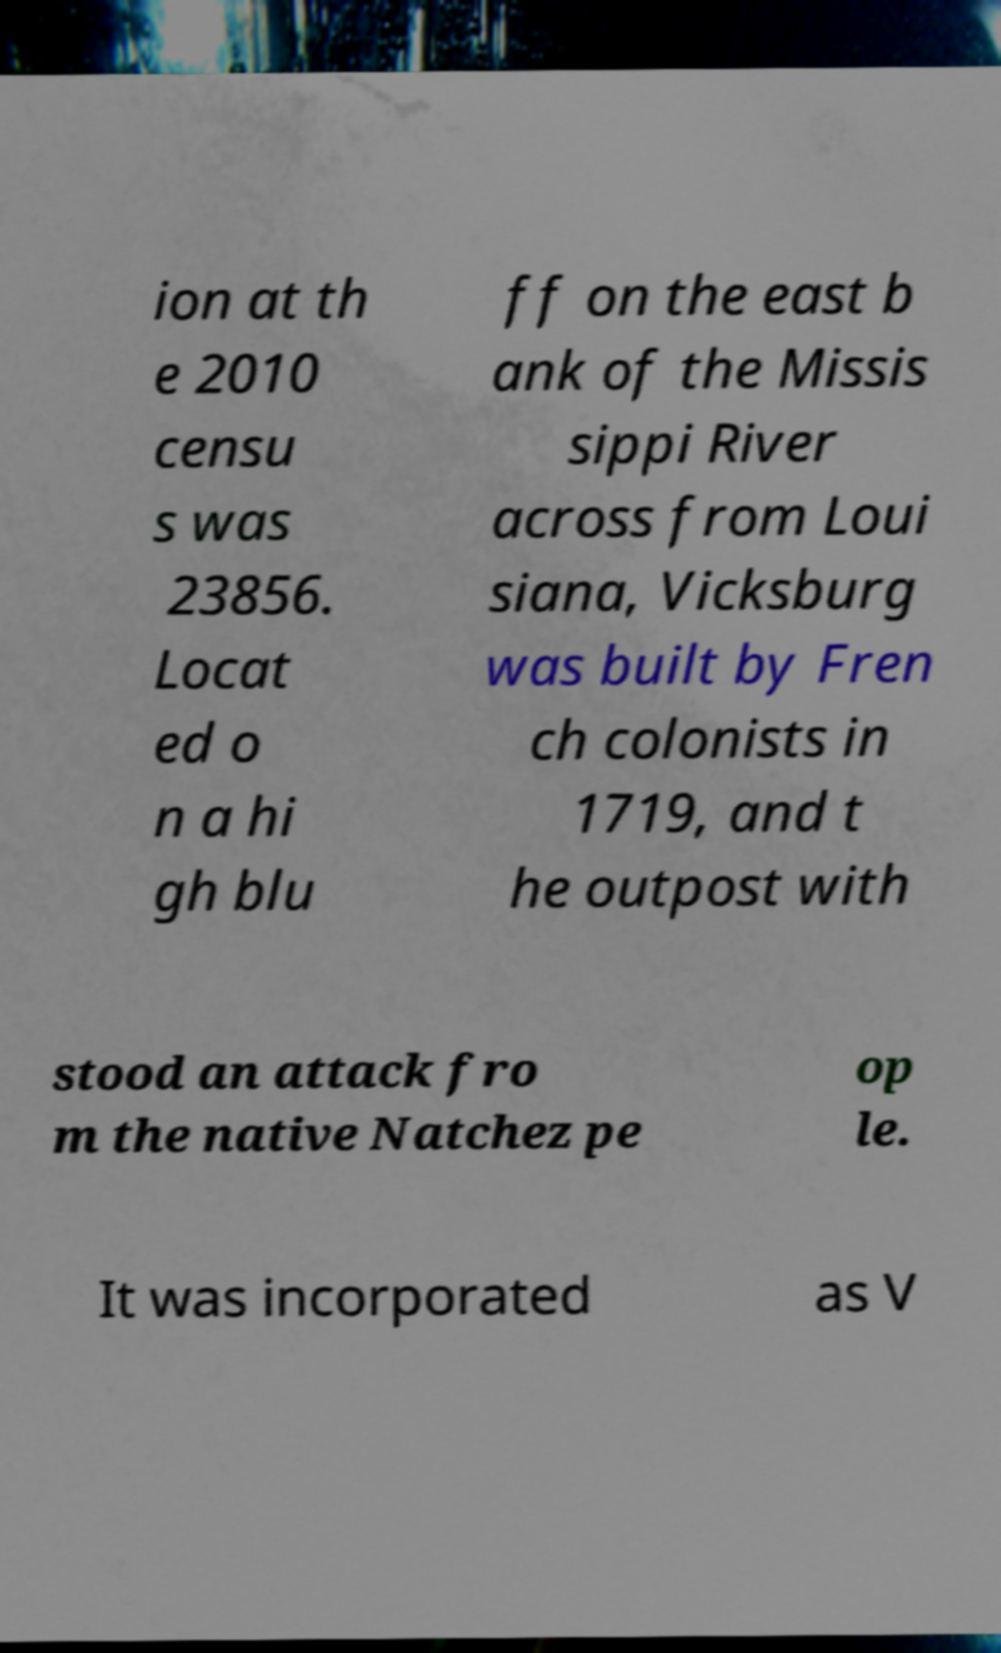What messages or text are displayed in this image? I need them in a readable, typed format. ion at th e 2010 censu s was 23856. Locat ed o n a hi gh blu ff on the east b ank of the Missis sippi River across from Loui siana, Vicksburg was built by Fren ch colonists in 1719, and t he outpost with stood an attack fro m the native Natchez pe op le. It was incorporated as V 